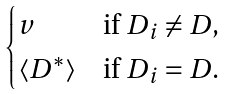Convert formula to latex. <formula><loc_0><loc_0><loc_500><loc_500>\begin{cases} v & \text {if $D_{i} \ne D$,} \\ \langle D ^ { * } \rangle & \text {if $D_{i} = D$.} \end{cases}</formula> 